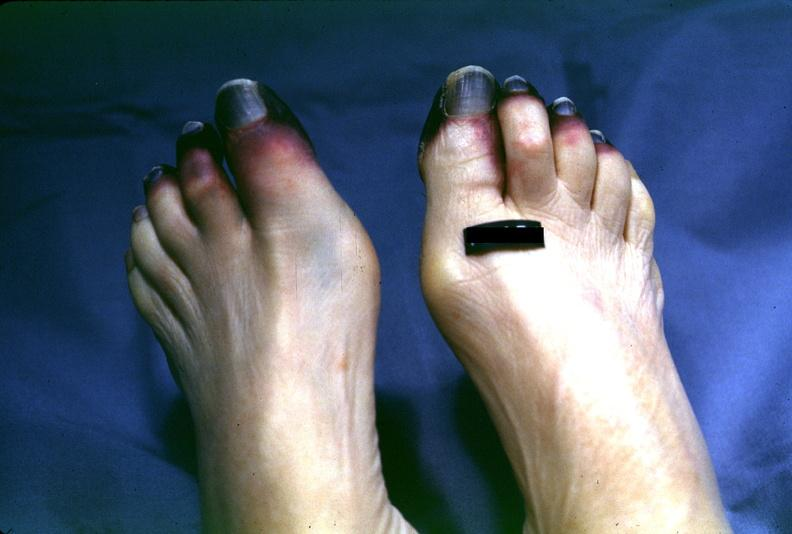does this image show toes, dry gangrene?
Answer the question using a single word or phrase. Yes 